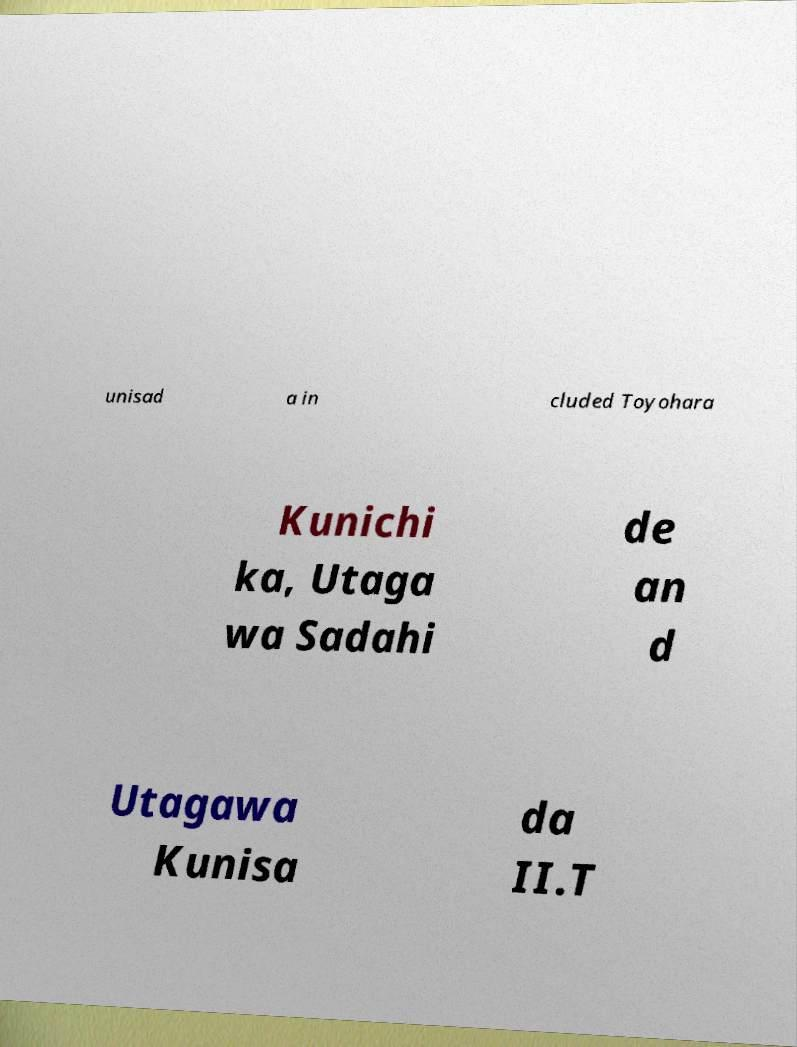Please identify and transcribe the text found in this image. unisad a in cluded Toyohara Kunichi ka, Utaga wa Sadahi de an d Utagawa Kunisa da II.T 